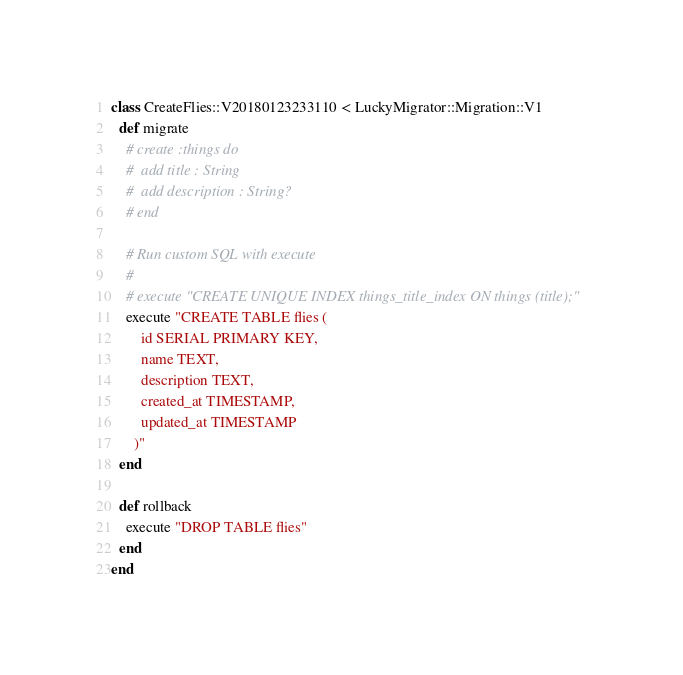<code> <loc_0><loc_0><loc_500><loc_500><_Crystal_>class CreateFlies::V20180123233110 < LuckyMigrator::Migration::V1
  def migrate
    # create :things do
    #  add title : String
    #  add description : String?
    # end

    # Run custom SQL with execute
    #
    # execute "CREATE UNIQUE INDEX things_title_index ON things (title);"
    execute "CREATE TABLE flies (
        id SERIAL PRIMARY KEY,
        name TEXT,
        description TEXT,
        created_at TIMESTAMP,
        updated_at TIMESTAMP
      )"
  end

  def rollback
    execute "DROP TABLE flies"
  end
end
</code> 